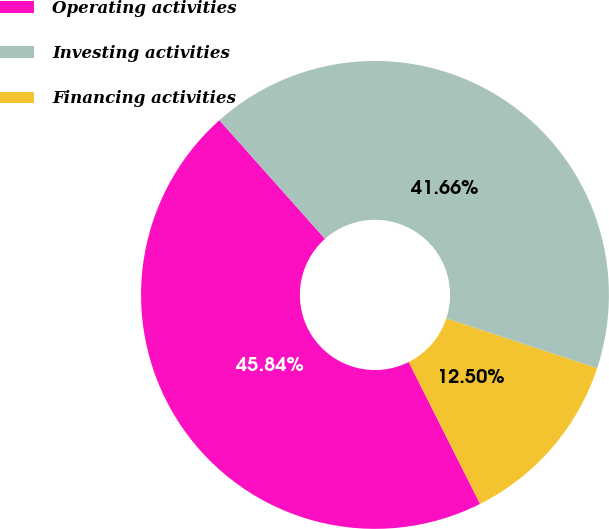<chart> <loc_0><loc_0><loc_500><loc_500><pie_chart><fcel>Operating activities<fcel>Investing activities<fcel>Financing activities<nl><fcel>45.84%<fcel>41.66%<fcel>12.5%<nl></chart> 